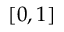Convert formula to latex. <formula><loc_0><loc_0><loc_500><loc_500>[ 0 , 1 ]</formula> 